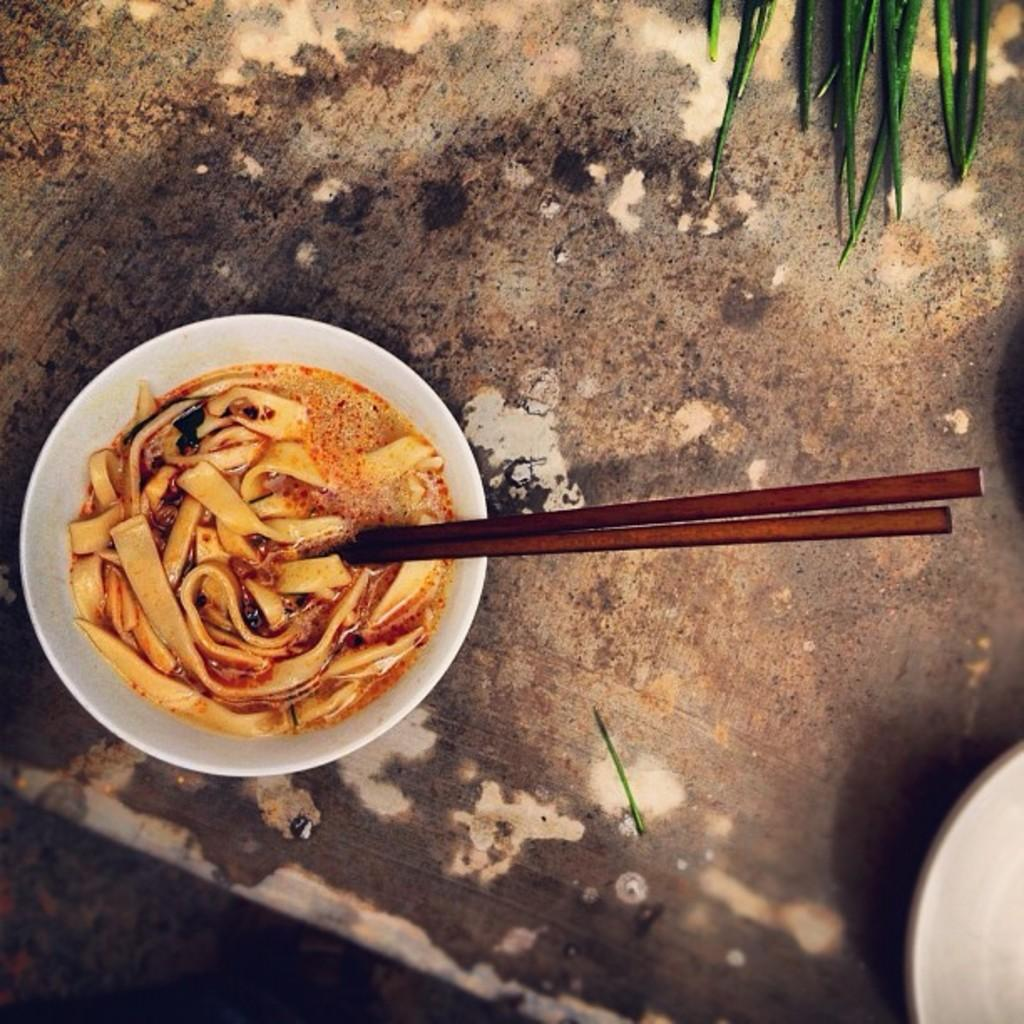What is in the bowl that is visible in the image? There is a bowl filled with noodles in the image. What utensil is present in the image? Chopsticks are present in the image. What type of food is visible in the image besides noodles? There are vegetables in the image. What is the dish used for in the image? There is a plate in the image. What type of wrench is visible in the image? There is no wrench present in the image. What mathematical operation is being performed in the image? There is no addition or any other mathematical operation being performed in the image. 